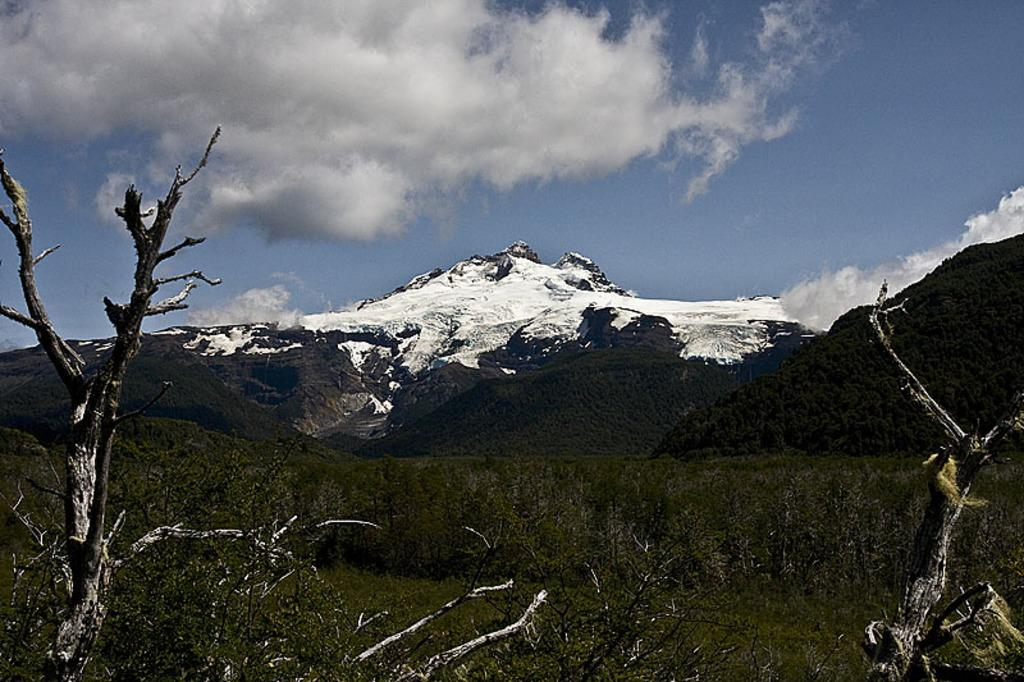What type of natural formation can be seen in the image? There are mountains in the image. What other natural elements are present in the image? There are trees, plants, and grass at the bottom of the image. What is visible at the top of the image? The sky is visible at the top of the image, and there are clouds in the sky. What is the purpose of the mountains in the image? The image does not provide information about the purpose of the mountains. Can you see anyone smashing the plants at the bottom of the image? There is no one present in the image who is smashing the plants. 